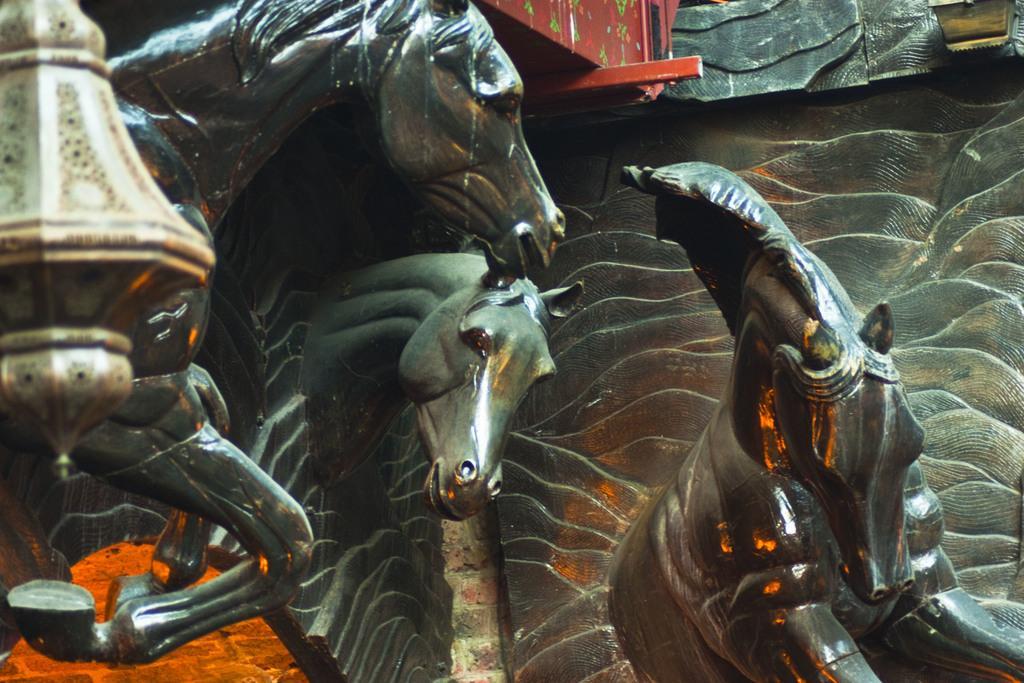Please provide a concise description of this image. There are few statues of horses and there are some other objects beside it. 